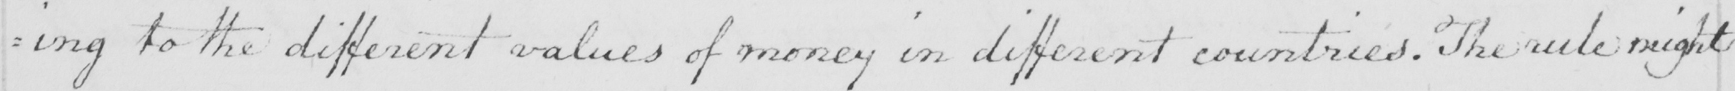What does this handwritten line say? : ing to the different values of money in different countries . The rule might 